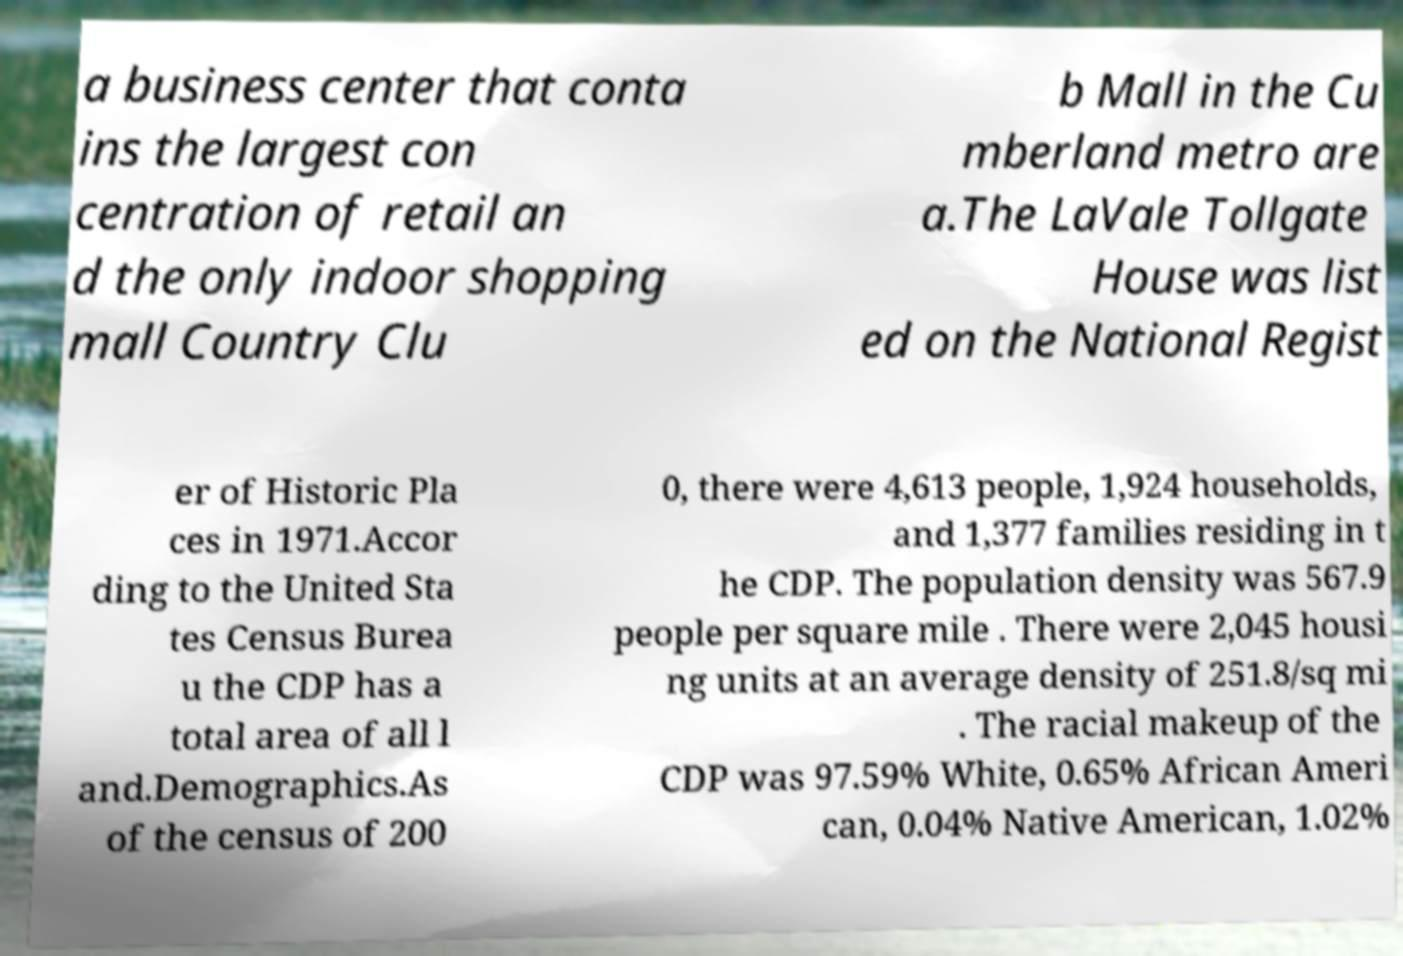I need the written content from this picture converted into text. Can you do that? a business center that conta ins the largest con centration of retail an d the only indoor shopping mall Country Clu b Mall in the Cu mberland metro are a.The LaVale Tollgate House was list ed on the National Regist er of Historic Pla ces in 1971.Accor ding to the United Sta tes Census Burea u the CDP has a total area of all l and.Demographics.As of the census of 200 0, there were 4,613 people, 1,924 households, and 1,377 families residing in t he CDP. The population density was 567.9 people per square mile . There were 2,045 housi ng units at an average density of 251.8/sq mi . The racial makeup of the CDP was 97.59% White, 0.65% African Ameri can, 0.04% Native American, 1.02% 